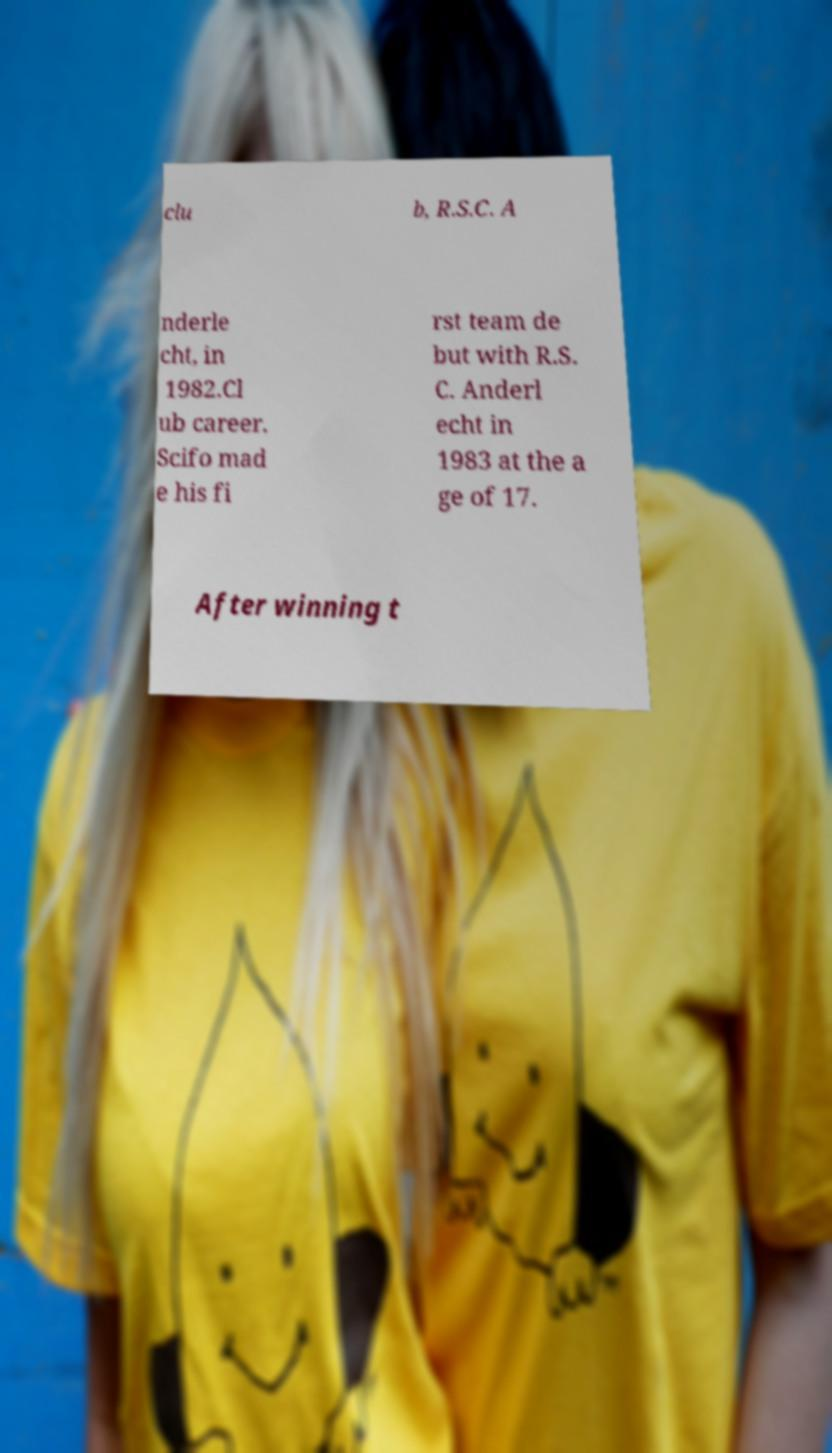Could you assist in decoding the text presented in this image and type it out clearly? clu b, R.S.C. A nderle cht, in 1982.Cl ub career. Scifo mad e his fi rst team de but with R.S. C. Anderl echt in 1983 at the a ge of 17. After winning t 